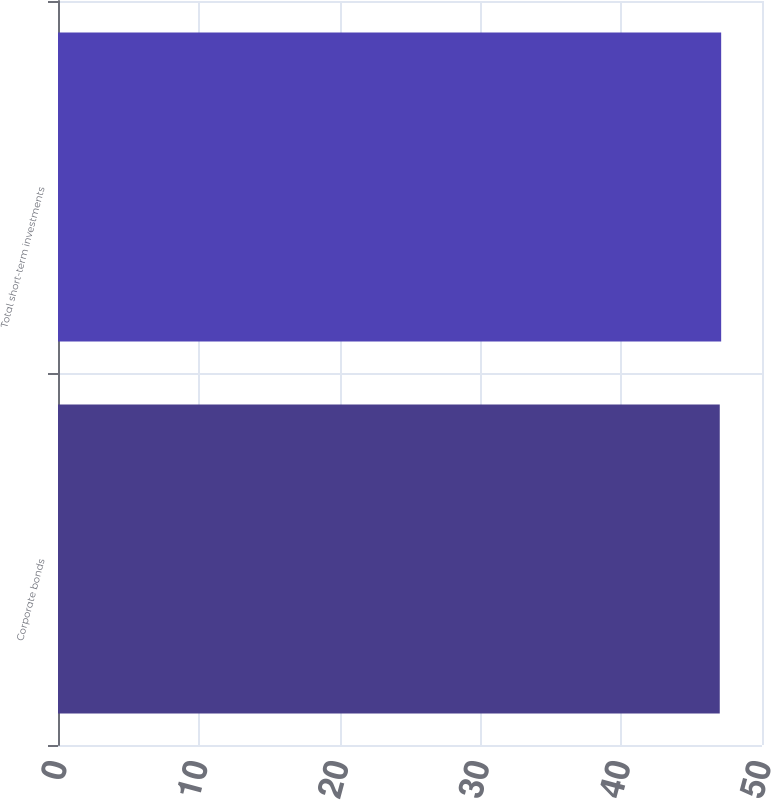<chart> <loc_0><loc_0><loc_500><loc_500><bar_chart><fcel>Corporate bonds<fcel>Total short-term investments<nl><fcel>47<fcel>47.1<nl></chart> 